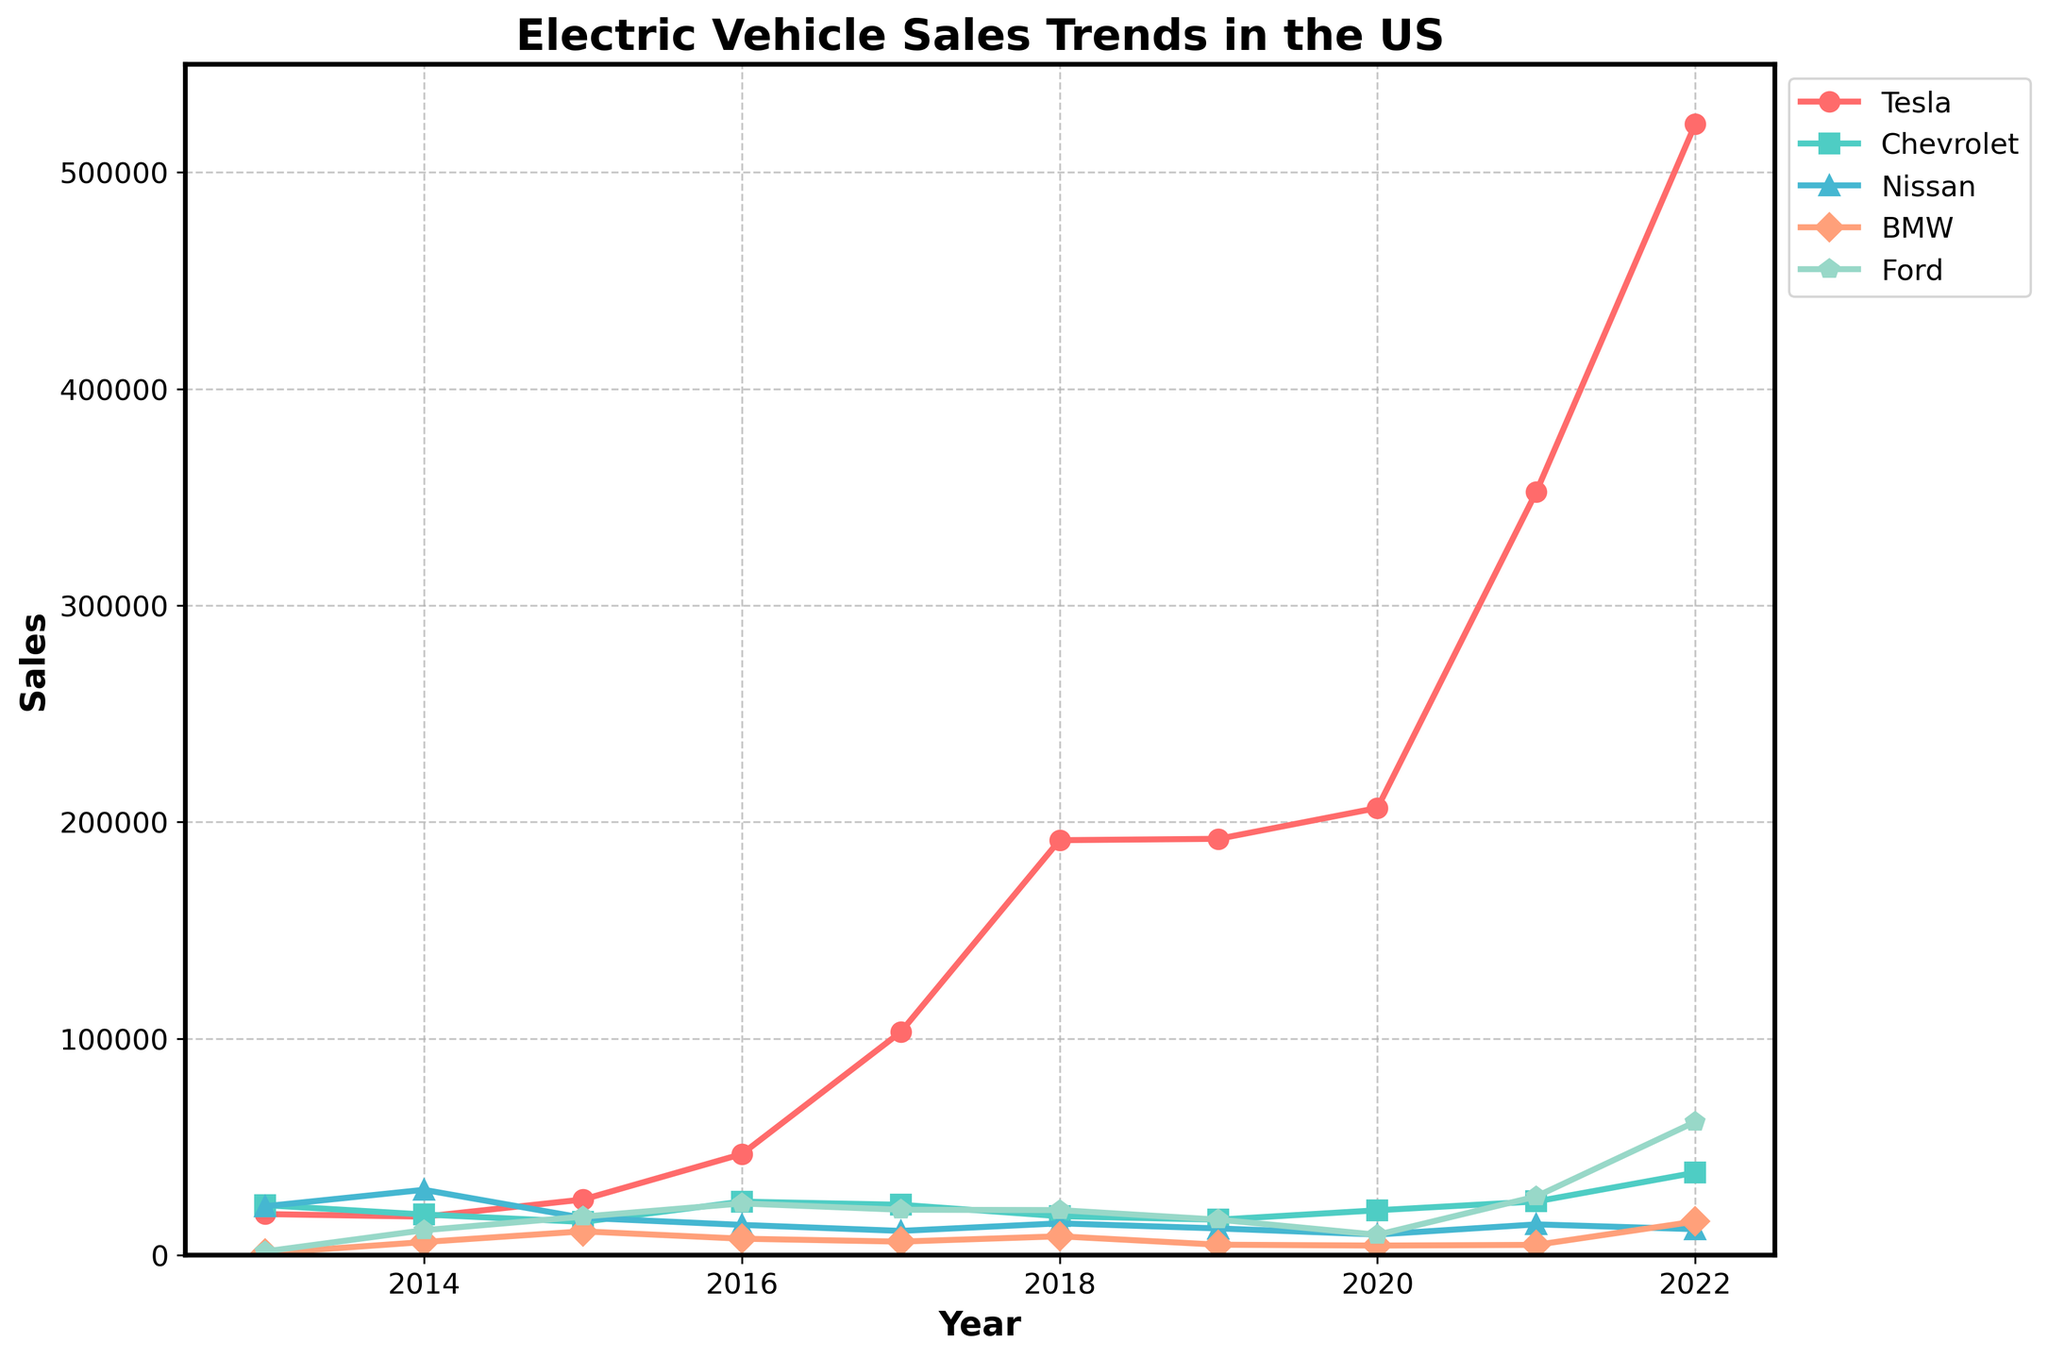What year did Tesla surpass 100,000 sales? The plot series labelled "Tesla" crosses the 100,000 sales mark between 2016 and 2017. By identifying the year where the sales spike noticeably above this value, we can pinpoint 2017 as the crossing year.
Answer: 2017 Which manufacturer had the highest sales in 2022? In 2022, the series for Tesla reaches the highest point, noticeably higher than other manufacturers, indicating Tesla had the highest sales in that year.
Answer: Tesla By how much did Chevrolet's sales increase from 2020 to 2022? Comparing the values in the plot for Chevrolet in 2020 and 2022, the sales increased from approximately 20,754 to 38,120. Calculating the difference (38,120 - 20,754) gives the increase.
Answer: 17,366 What is the general trend of Nissan's EV sales over the decade? Observing the series for Nissan, there are fluctuations but a noticeable decline from the beginning (2013) to the end (2022) of the decade.
Answer: Declining Between 2018 and 2022, which manufacturer experienced the largest relative increase in sales? From the chart, Tesla's sales show the most dramatic increase in height between 2018 and 2022, suggesting the largest relative increase.
Answer: Tesla Which year saw the biggest single-year sales increase for Ford? Tracking the Ford series visually, the year with the steepest increase is between 2021 and 2022.
Answer: 2021-2022 Comparing Tesla and BMW in 2020, how many more units did Tesla sell? For 2020, the difference in sales between Tesla and BMW is the difference between their plot heights: 206,500 (Tesla) and 4,457 (BMW). The difference is 206,500 - 4,457.
Answer: 202,043 What was the trend for BMW from 2019 to 2021? Visually, the BMW series line remains rather flat from 2019 to 2020, and then there is a slight increase in 2021.
Answer: Slight increase Rank the manufacturers by their sales in 2015. By comparing the relative heights of the series in 2015, the ranking from highest to lowest is: BMW, Ford, Tesla, Nissan, Chevrolet.
Answer: BMW, Ford, Tesla, Nissan, Chevrolet What year did Chevrolet reach its lowest sales? By examining the series for Chevrolet, the lowest point in the trend appears around 2019.
Answer: 2019 